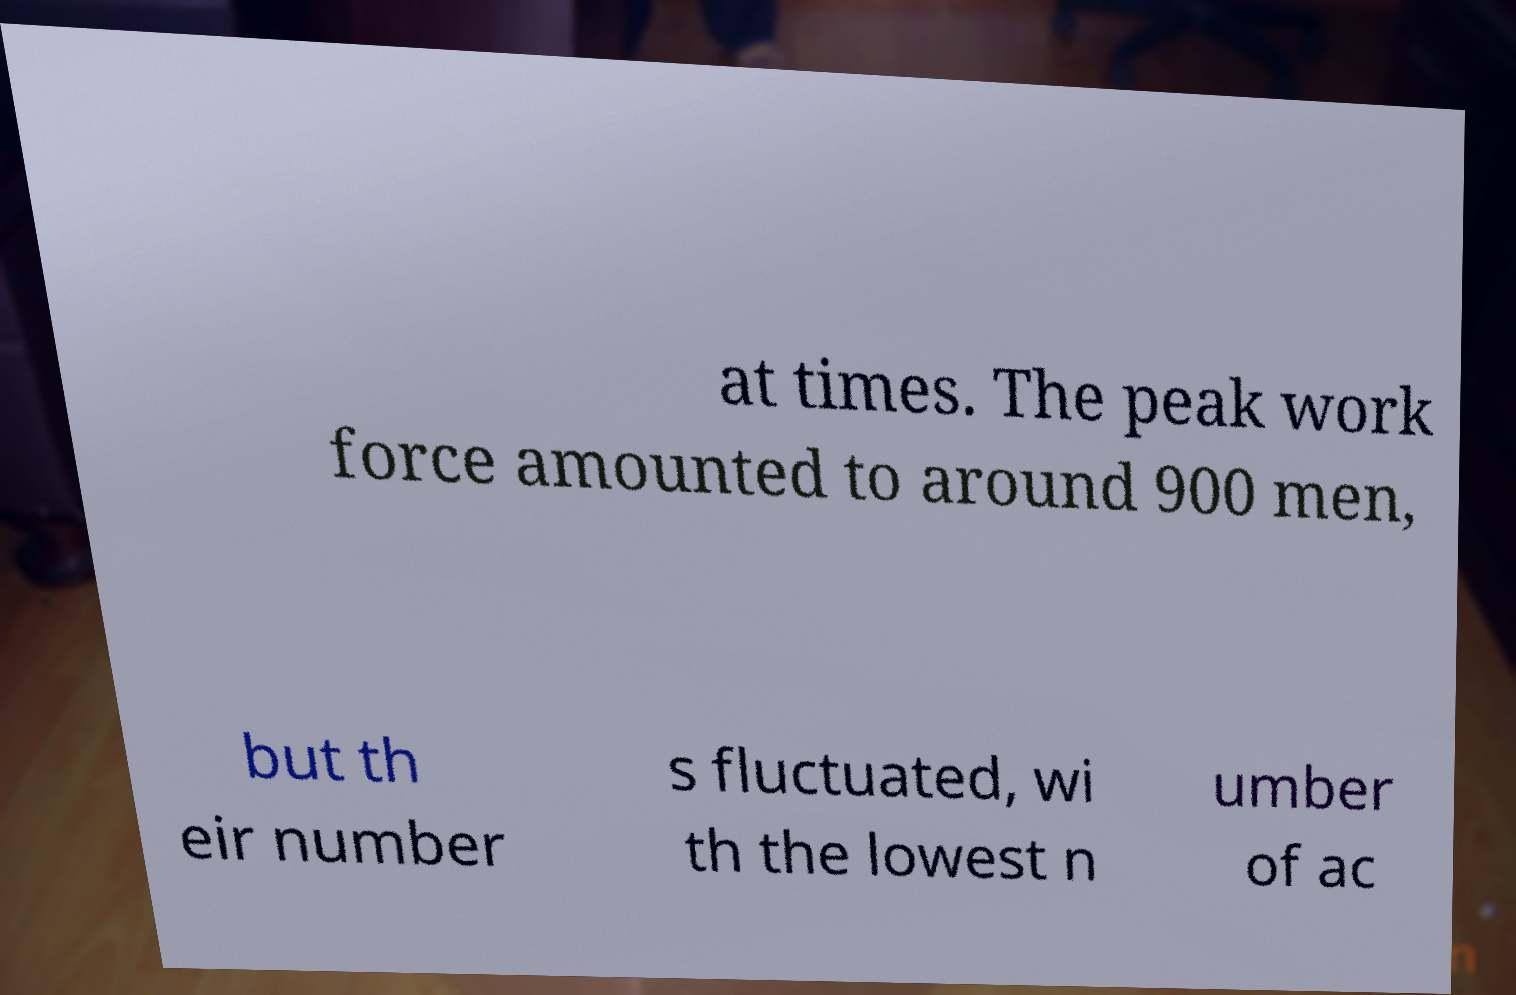There's text embedded in this image that I need extracted. Can you transcribe it verbatim? at times. The peak work force amounted to around 900 men, but th eir number s fluctuated, wi th the lowest n umber of ac 